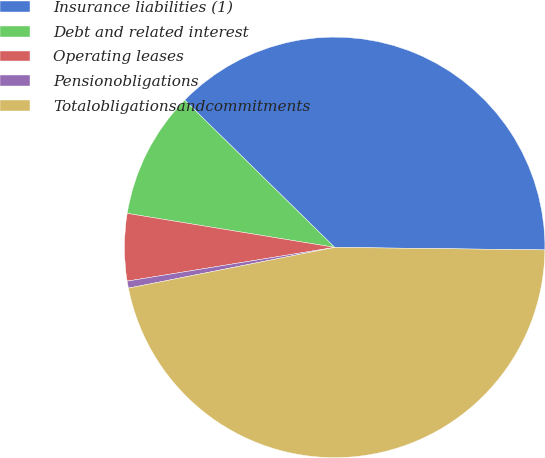<chart> <loc_0><loc_0><loc_500><loc_500><pie_chart><fcel>Insurance liabilities (1)<fcel>Debt and related interest<fcel>Operating leases<fcel>Pensionobligations<fcel>Totalobligationsandcommitments<nl><fcel>37.84%<fcel>9.77%<fcel>5.15%<fcel>0.54%<fcel>46.7%<nl></chart> 